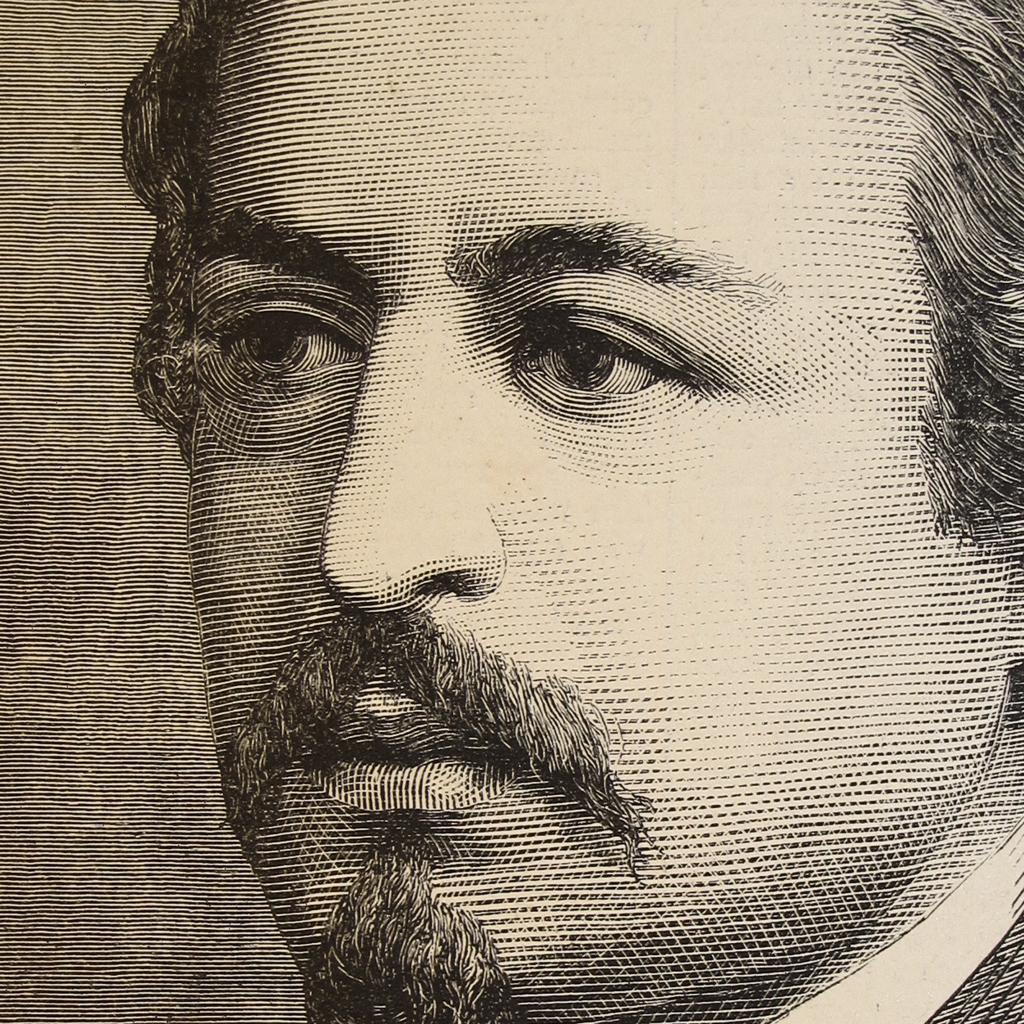Can you describe this image briefly? In this picture we can see a sketch of a person's face. 